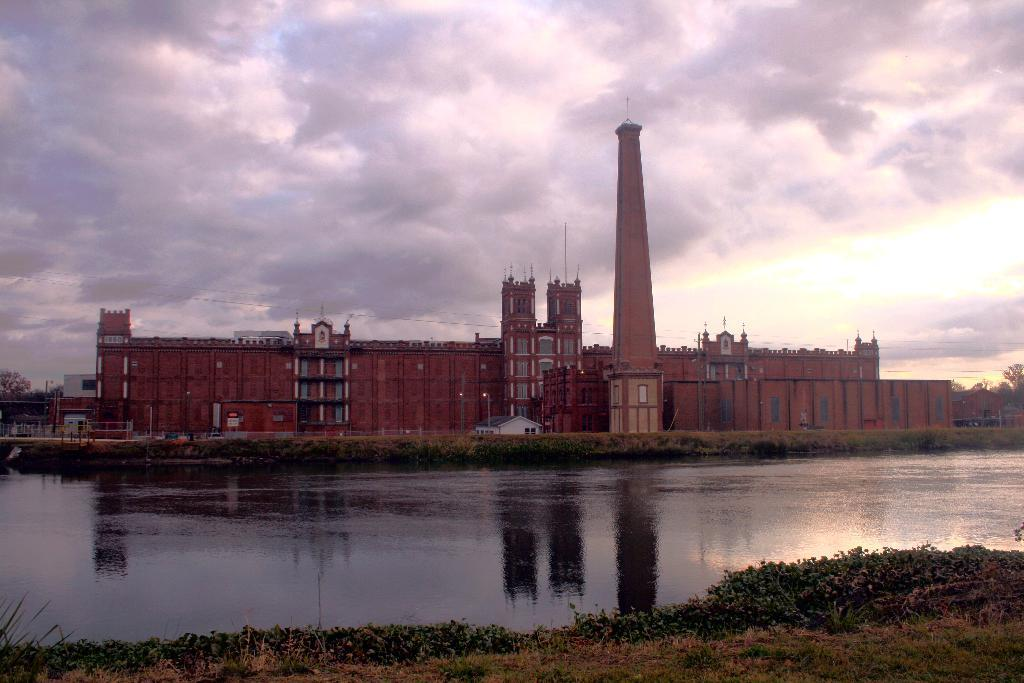What type of building is in the image? There is a palace in the image. What is located in front of the palace? There is a lake in front of the palace. What can be seen at the top of the image? The sky is visible at the top of the image. What is the source of light in the image? Sunlight is present in the image. Can you describe the stew that is being served in the palace's dining hall in the image? There is no dining hall or stew present in the image; it only shows a palace and a lake in front of it. 